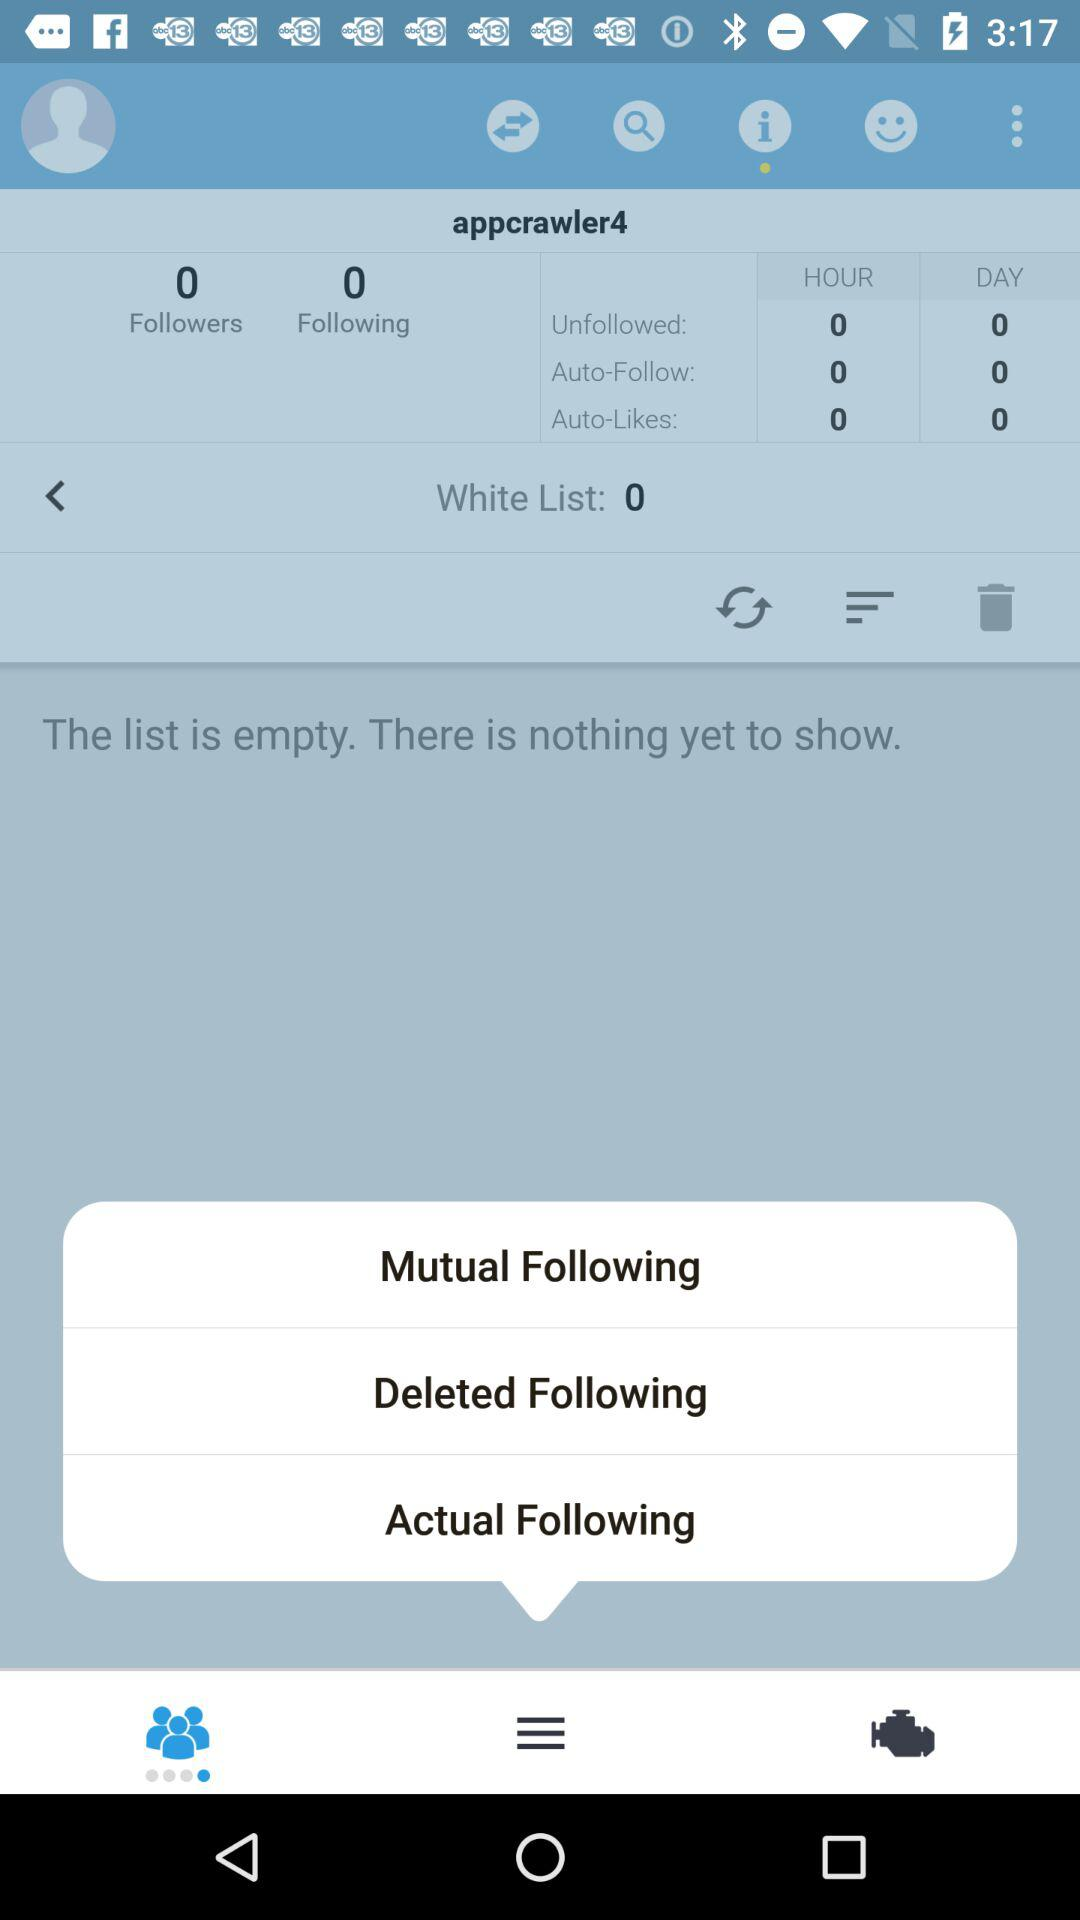What is the name of the user? The name of the user is appcrawler4. 